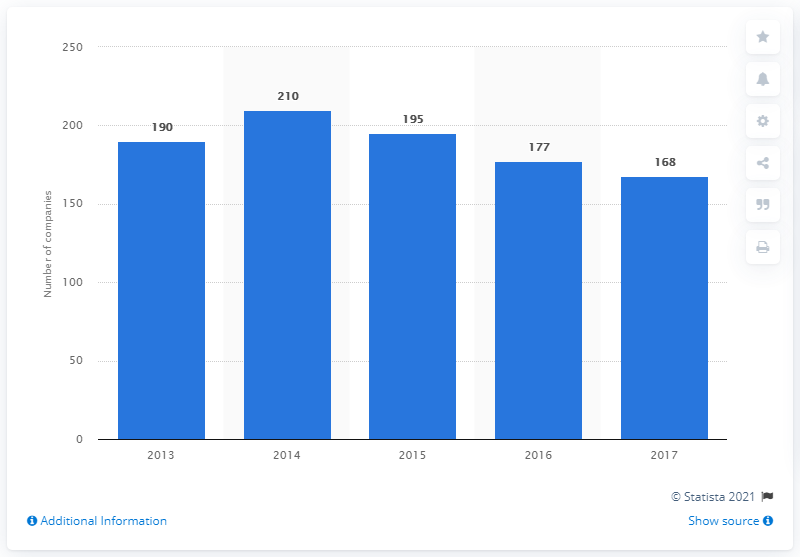Point out several critical features in this image. The statistics reveal that in the year 2013, there were a significant number of life insurance companies with their headquarters located in the United Kingdom. As of the end of 2017, there were 168 life insurance companies headquartered in the UK. 